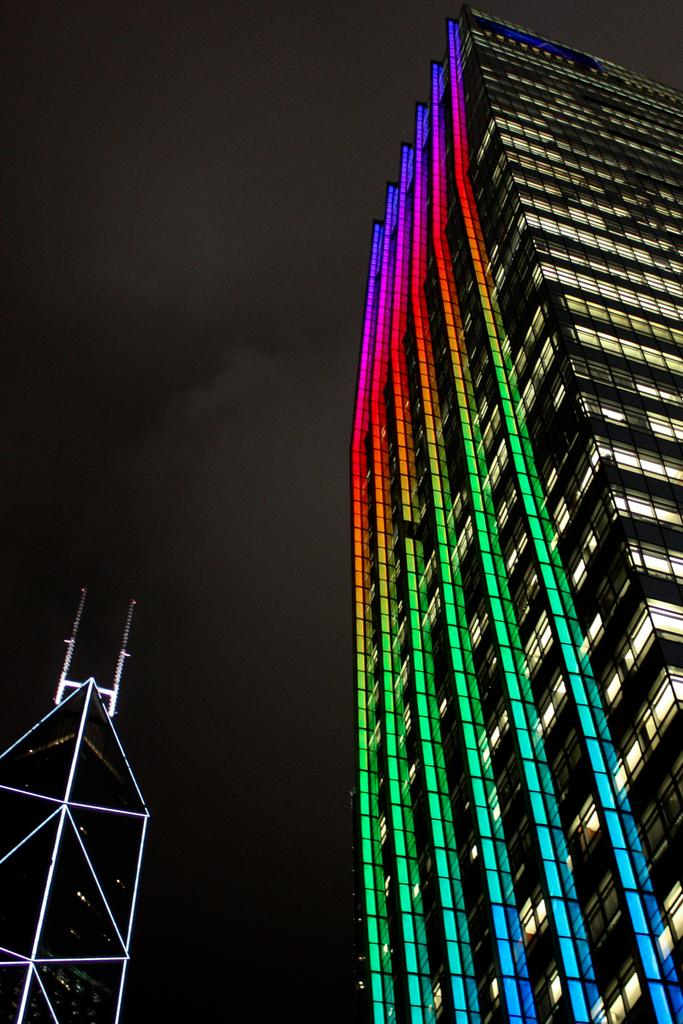What structure is located on the right side of the image? There is a building on the right side of the image. What feature can be observed on the building in the image? There are colorful lights on the building. What is the current tax rate for the building in the image? There is no information about tax rates in the image, as it only shows a building with colorful lights. 